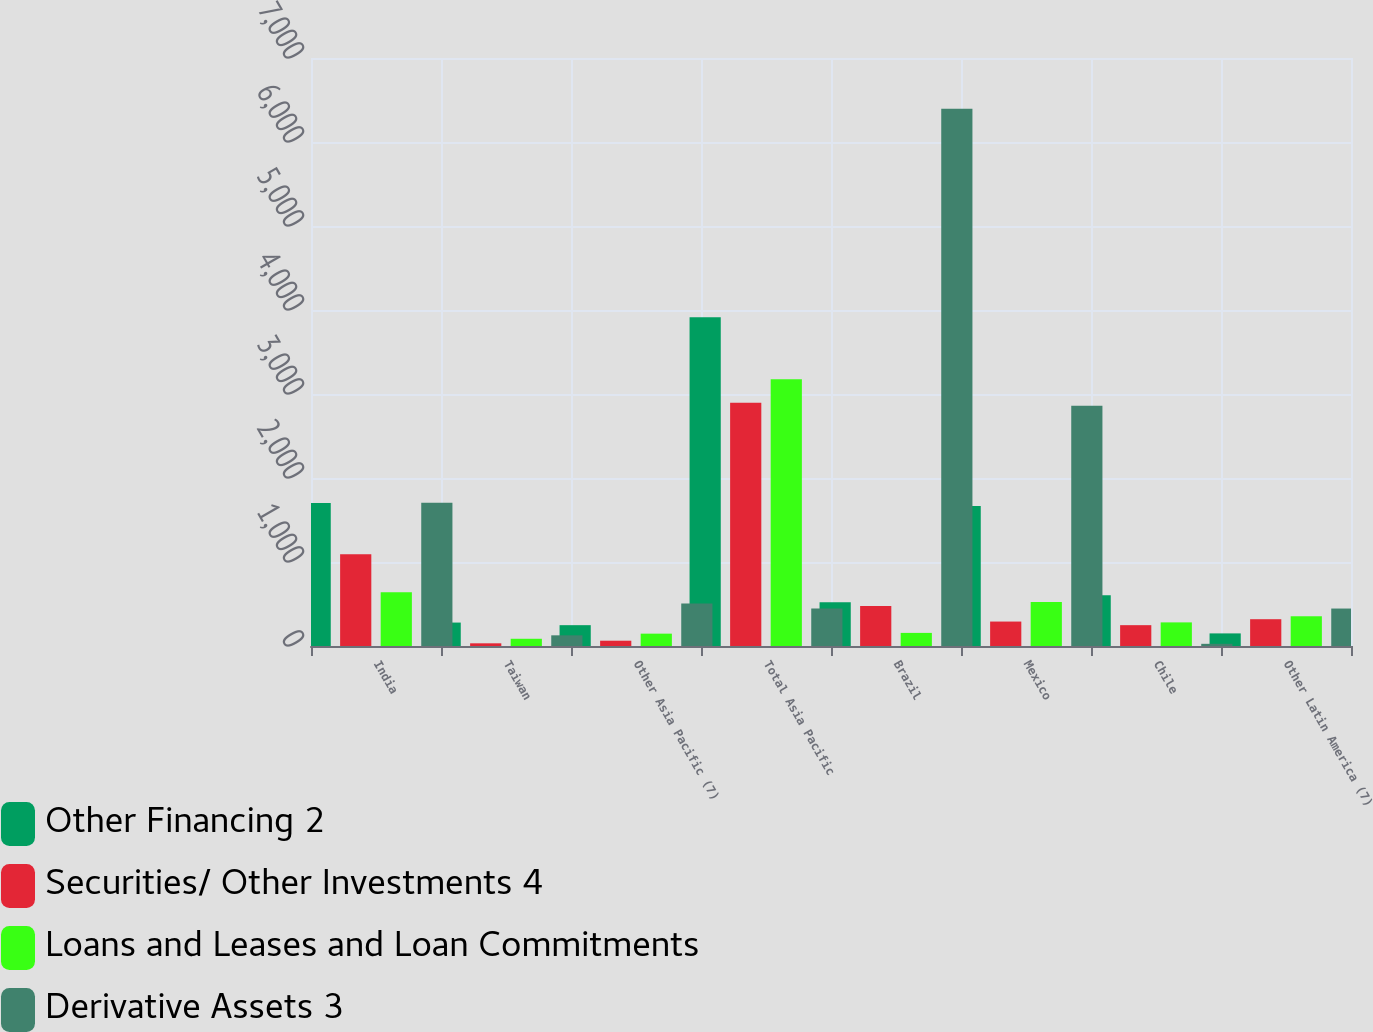Convert chart to OTSL. <chart><loc_0><loc_0><loc_500><loc_500><stacked_bar_chart><ecel><fcel>India<fcel>Taiwan<fcel>Other Asia Pacific (7)<fcel>Total Asia Pacific<fcel>Brazil<fcel>Mexico<fcel>Chile<fcel>Other Latin America (7)<nl><fcel>Other Financing 2<fcel>1702<fcel>279<fcel>248<fcel>3913<fcel>522<fcel>1667<fcel>604<fcel>150<nl><fcel>Securities/ Other Investments 4<fcel>1091<fcel>32<fcel>63<fcel>2897<fcel>475<fcel>291<fcel>248<fcel>319<nl><fcel>Loans and Leases and Loan Commitments<fcel>639<fcel>86<fcel>147<fcel>3177<fcel>156<fcel>524<fcel>281<fcel>354<nl><fcel>Derivative Assets 3<fcel>1704<fcel>127<fcel>505<fcel>446<fcel>6396<fcel>2860<fcel>26<fcel>446<nl></chart> 